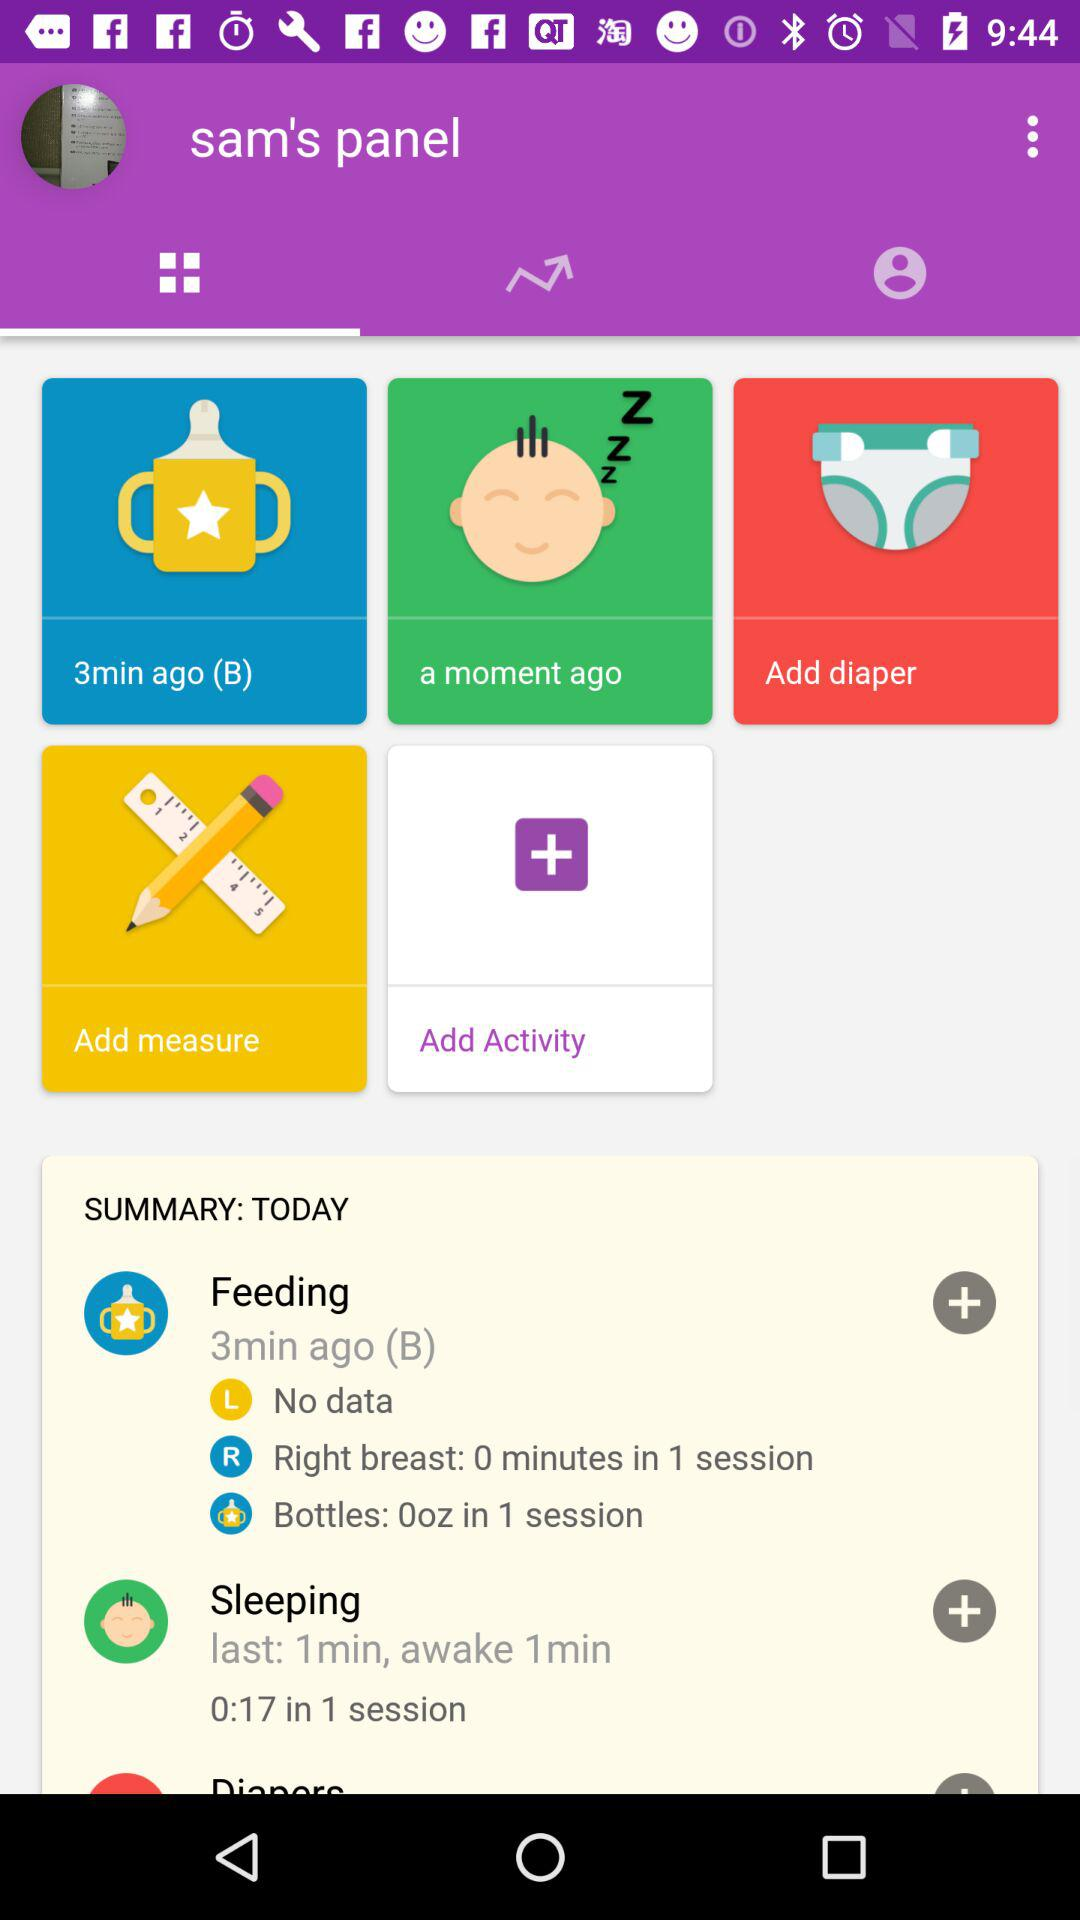How many minutes ago did the baby drink milk? The baby drank milk 3 minutes ago. 